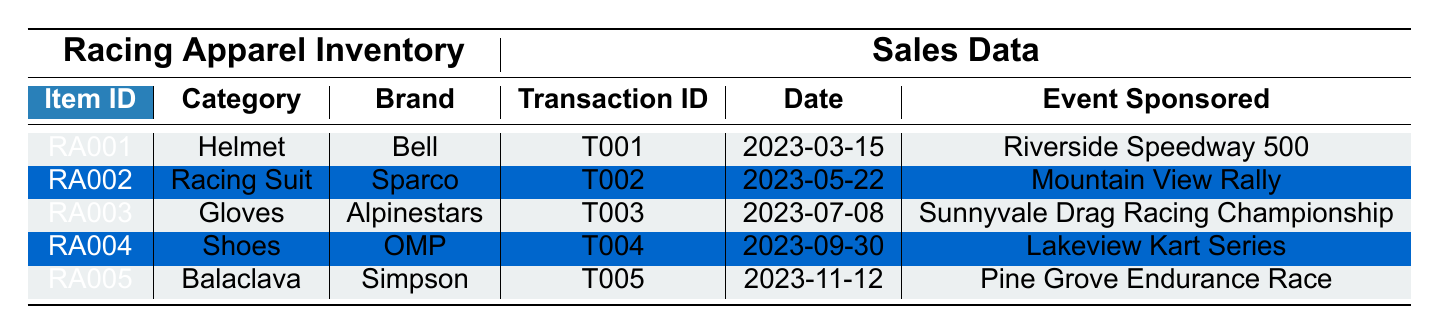What is the selling price of the Racing Suit by Sparco? The selling price can be found in the inventory section under the category "Racing Suit" for the brand "Sparco". It is listed as 799.99.
Answer: 799.99 How many items of Gloves were sold on July 8, 2023? The sales data shows the transaction for Gloves (item ID: RA003) on July 8, 2023, with a quantity sold of 5.
Answer: 5 What is the total revenue generated from selling the Balaclava? The total sale for the Balaclava (item ID: RA005) is found in the sales data entry for the transaction ID T005, which is 399.90.
Answer: 399.90 What are the colors available for inventory items? By reviewing the inventory section, the available colors are Red, Blue, Black, White, and Black (from the Balaclava).
Answer: Red, Blue, Black, White Did John Smith purchase more than one Racing Suit? The sales data shows that John Smith purchased a Helmet (item ID: RA001), not a Racing Suit. Therefore, the answer is no, as he did not purchase any Racing Suit.
Answer: No Which event had the highest total sale amount recorded? The largest total sale amount in the sales data can be found from the transactions. The highest amount is 799.99 for the Racing Suit (T002).
Answer: Racing Suit - 799.99 What is the average selling price of items sold on the date of 2023-03-15? On March 15, 2023, only one item was sold (Helmet) at the price of 249.99. Therefore, the average selling price is equal to that single item’s price, which is 249.99.
Answer: 249.99 How many total items are available in stock for all categories combined? Summing up the quantities in the inventory: 15 (Helmet) + 8 (Racing Suit) + 25 (Gloves) + 12 (Shoes) + 30 (Balaclava) equals 90 items available in stock.
Answer: 90 What was the total sale amount for Shoes sold at the Lakeview Kart Series? For the transaction of Shoes (item ID: RA004) during the Lakeview Kart Series on 2023-09-30, the total sale amount recorded is 539.97.
Answer: 539.97 Was the total revenue from the Gloves equal to the revenue from the Helmet sold? The total sales from Gloves are 449.95 (T003), and from the Helmet, it is 499.98 (T001). Since 449.95 does not equal 499.98, the answer is no.
Answer: No 